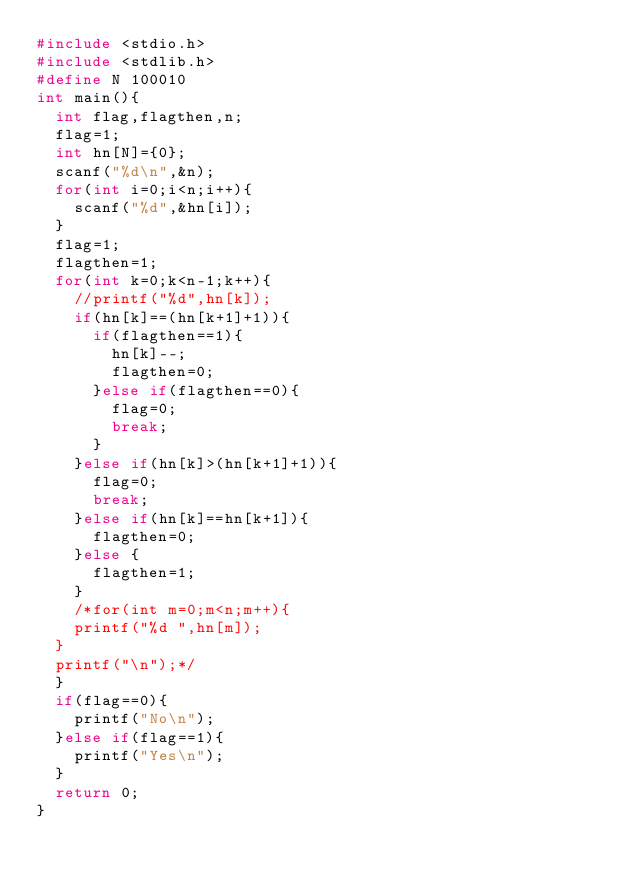Convert code to text. <code><loc_0><loc_0><loc_500><loc_500><_C++_>#include <stdio.h>
#include <stdlib.h>
#define N 100010
int main(){
	int flag,flagthen,n;
	flag=1;
	int hn[N]={0};
	scanf("%d\n",&n);
	for(int i=0;i<n;i++){
		scanf("%d",&hn[i]);
	}
	flag=1;
	flagthen=1;
	for(int k=0;k<n-1;k++){
		//printf("%d",hn[k]);
		if(hn[k]==(hn[k+1]+1)){
			if(flagthen==1){
				hn[k]--;
				flagthen=0;
			}else if(flagthen==0){
				flag=0;
				break;
			}
		}else if(hn[k]>(hn[k+1]+1)){
			flag=0;
			break;
		}else if(hn[k]==hn[k+1]){
			flagthen=0;
		}else {
			flagthen=1;
		}
		/*for(int m=0;m<n;m++){
		printf("%d ",hn[m]);
	}
	printf("\n");*/
	}
	if(flag==0){
		printf("No\n");
	}else if(flag==1){
		printf("Yes\n");
	}
	return 0;
}</code> 